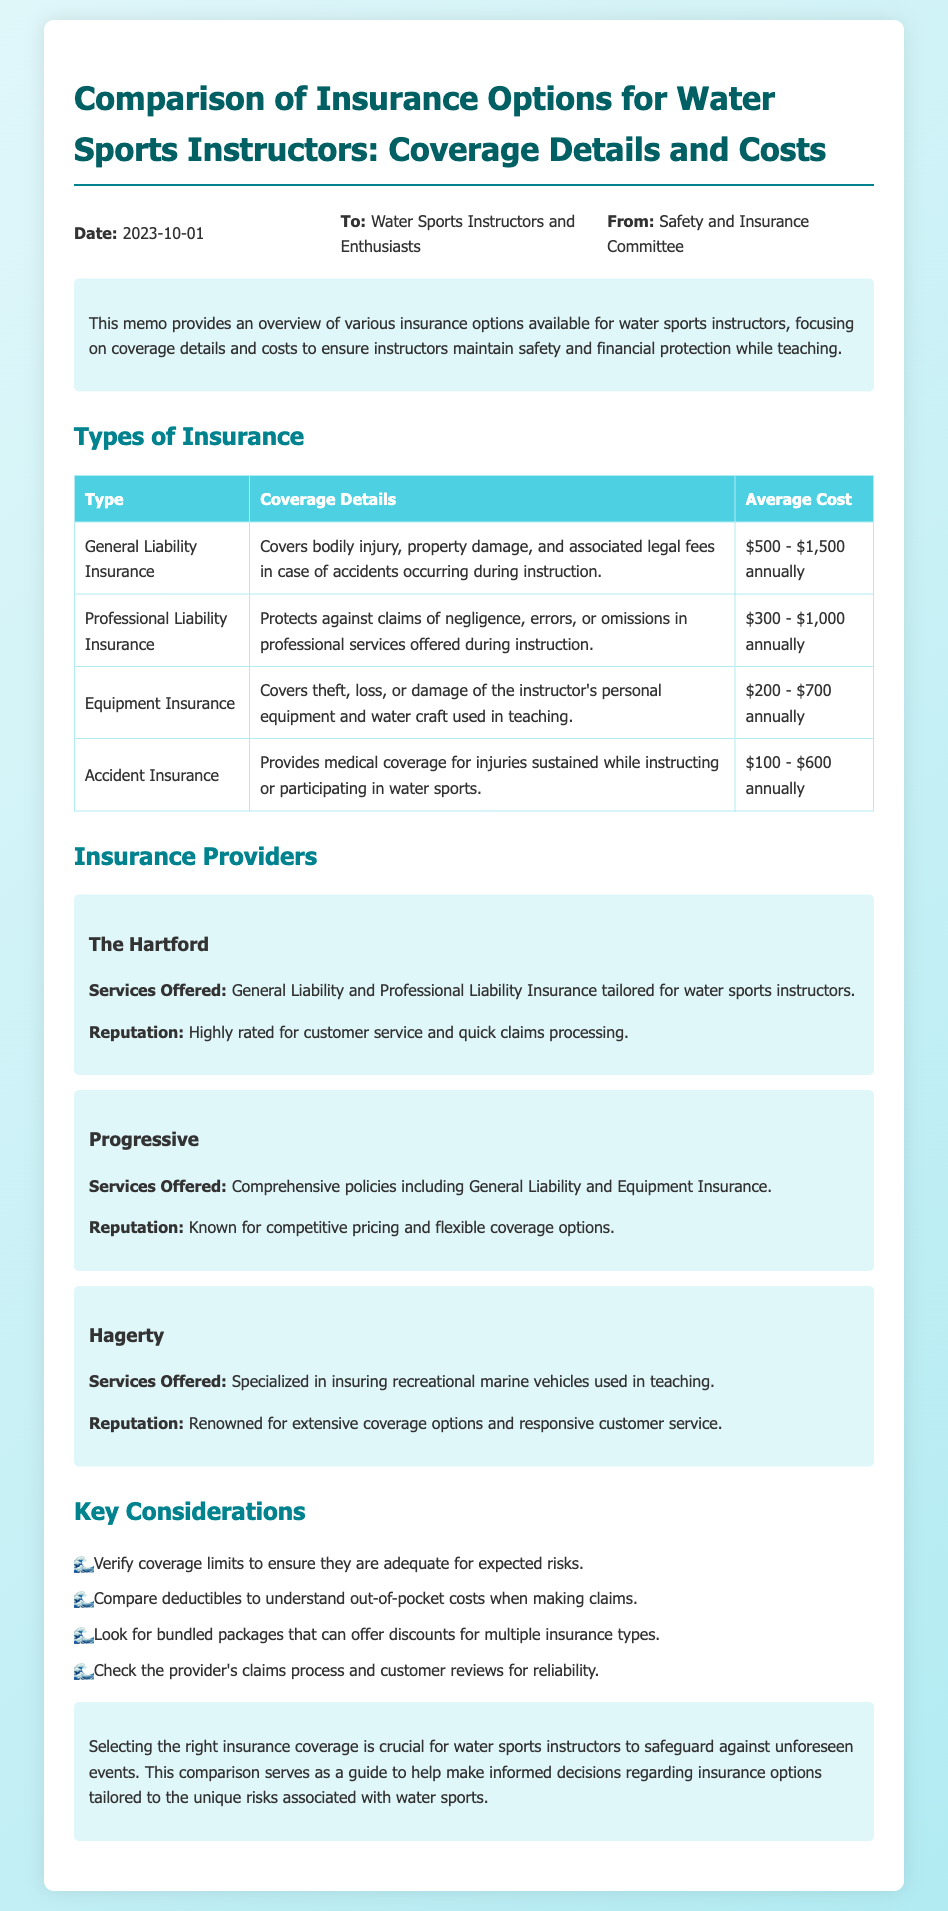what is the date of the memo? The date is specifically mentioned at the top of the document under the header section.
Answer: 2023-10-01 who is the memo addressed to? The memo specifies the recipient in the header section, indicating who should receive the information.
Answer: Water Sports Instructors and Enthusiasts what type of insurance covers bodily injury during instruction? The coverage details for each type of insurance are listed in the table; this one specifies the coverage for bodily injury.
Answer: General Liability Insurance what is the average cost range for Professional Liability Insurance? The average costs for each type of insurance are provided in the table, which details annual cost ranges.
Answer: $300 - $1,000 annually which insurance provider is known for competitive pricing? Each provider's reputation is detailed, indicating their standing in the insurance market.
Answer: Progressive how many key considerations are listed in the document? The document lists specific considerations that should be kept in mind while selecting insurance; counting these gives the total.
Answer: Four which insurance covers theft of equipment? The table outlines the types of insurance and their coverage details, identifying the purpose of each.
Answer: Equipment Insurance what services does Hagerty specialize in? The services offered by each provider are mentioned in their respective sections, detailing specific areas of expertise.
Answer: Insuring recreational marine vehicles 